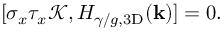Convert formula to latex. <formula><loc_0><loc_0><loc_500><loc_500>\begin{array} { r } { [ \sigma _ { x } \tau _ { x } \mathcal { K } , H _ { \gamma / g , 3 D } ( k ) ] = 0 . } \end{array}</formula> 